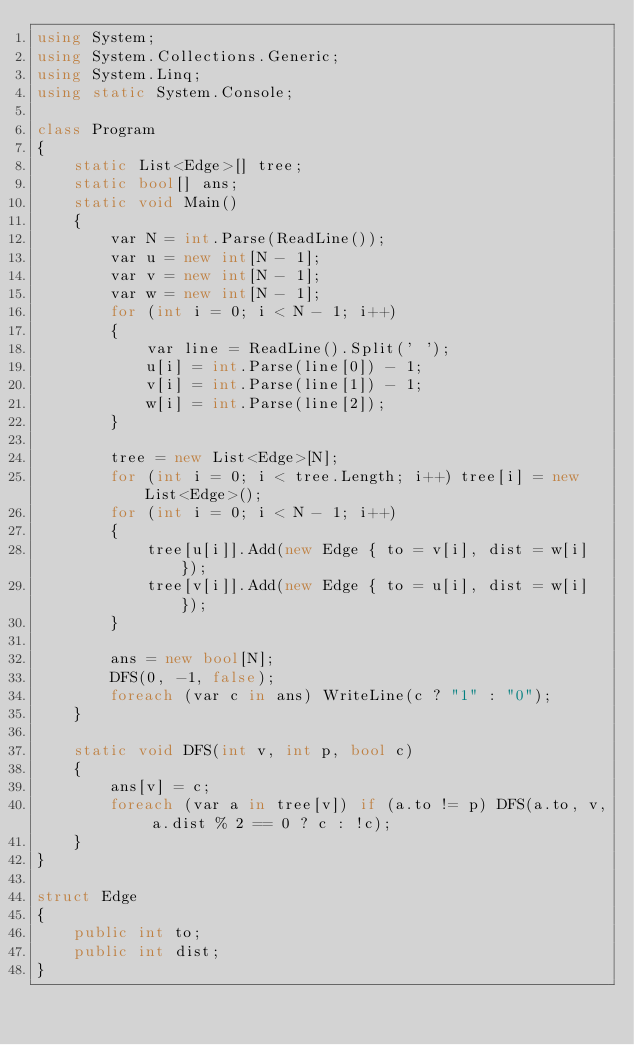Convert code to text. <code><loc_0><loc_0><loc_500><loc_500><_C#_>using System;
using System.Collections.Generic;
using System.Linq;
using static System.Console;

class Program
{
    static List<Edge>[] tree;
    static bool[] ans;
    static void Main()
    {
        var N = int.Parse(ReadLine());
        var u = new int[N - 1];
        var v = new int[N - 1];
        var w = new int[N - 1];
        for (int i = 0; i < N - 1; i++)
        {
            var line = ReadLine().Split(' ');
            u[i] = int.Parse(line[0]) - 1;
            v[i] = int.Parse(line[1]) - 1;
            w[i] = int.Parse(line[2]);
        }

        tree = new List<Edge>[N];
        for (int i = 0; i < tree.Length; i++) tree[i] = new List<Edge>();
        for (int i = 0; i < N - 1; i++)
        {
            tree[u[i]].Add(new Edge { to = v[i], dist = w[i] });
            tree[v[i]].Add(new Edge { to = u[i], dist = w[i] });
        }

        ans = new bool[N];
        DFS(0, -1, false);
        foreach (var c in ans) WriteLine(c ? "1" : "0");
    }

    static void DFS(int v, int p, bool c)
    {
        ans[v] = c;
        foreach (var a in tree[v]) if (a.to != p) DFS(a.to, v, a.dist % 2 == 0 ? c : !c);
    }
}

struct Edge
{
    public int to;
    public int dist;
}
</code> 